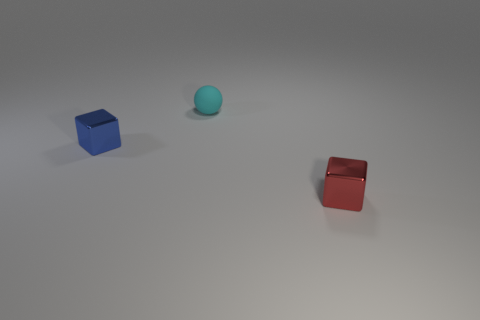Add 1 blue metal objects. How many objects exist? 4 Subtract all blocks. How many objects are left? 1 Subtract all small yellow rubber things. Subtract all tiny matte objects. How many objects are left? 2 Add 3 cyan spheres. How many cyan spheres are left? 4 Add 3 metallic cubes. How many metallic cubes exist? 5 Subtract 0 yellow blocks. How many objects are left? 3 